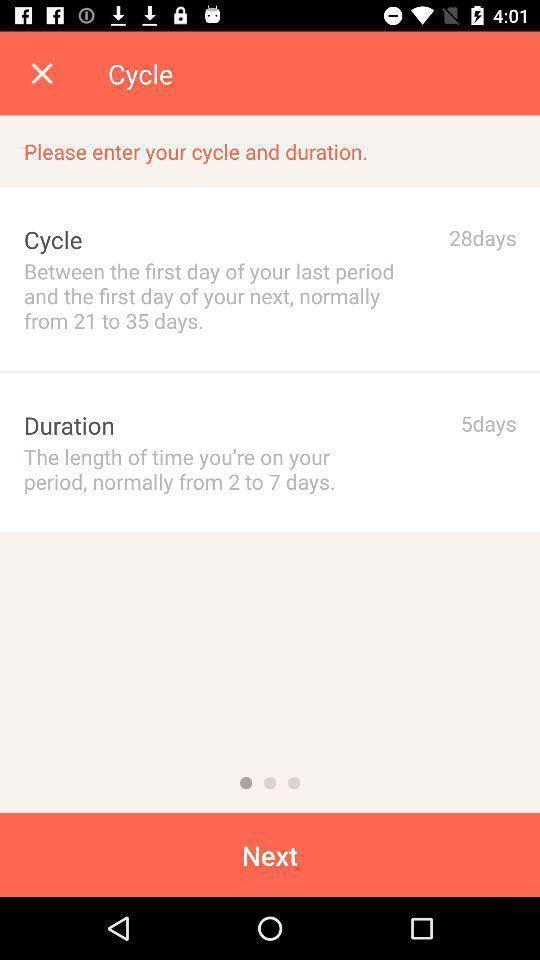Describe the visual elements of this screenshot. Screen displaying input field to enter cycle and duration details. 